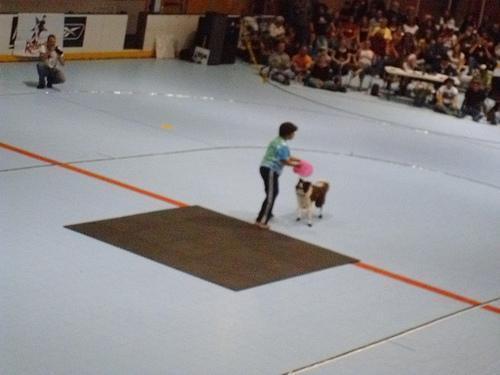How many people are visible?
Give a very brief answer. 2. 